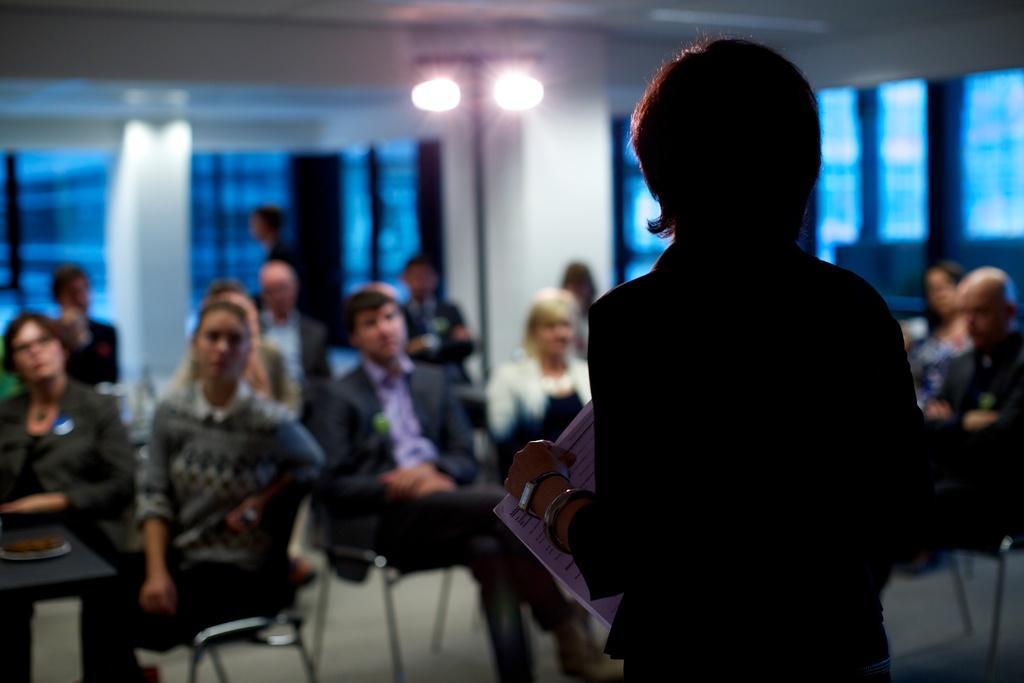Can you describe this image briefly? In this image we can see a person and papers. In the background of the image there are persons, chairs, lights, wall, windows and other objects. 